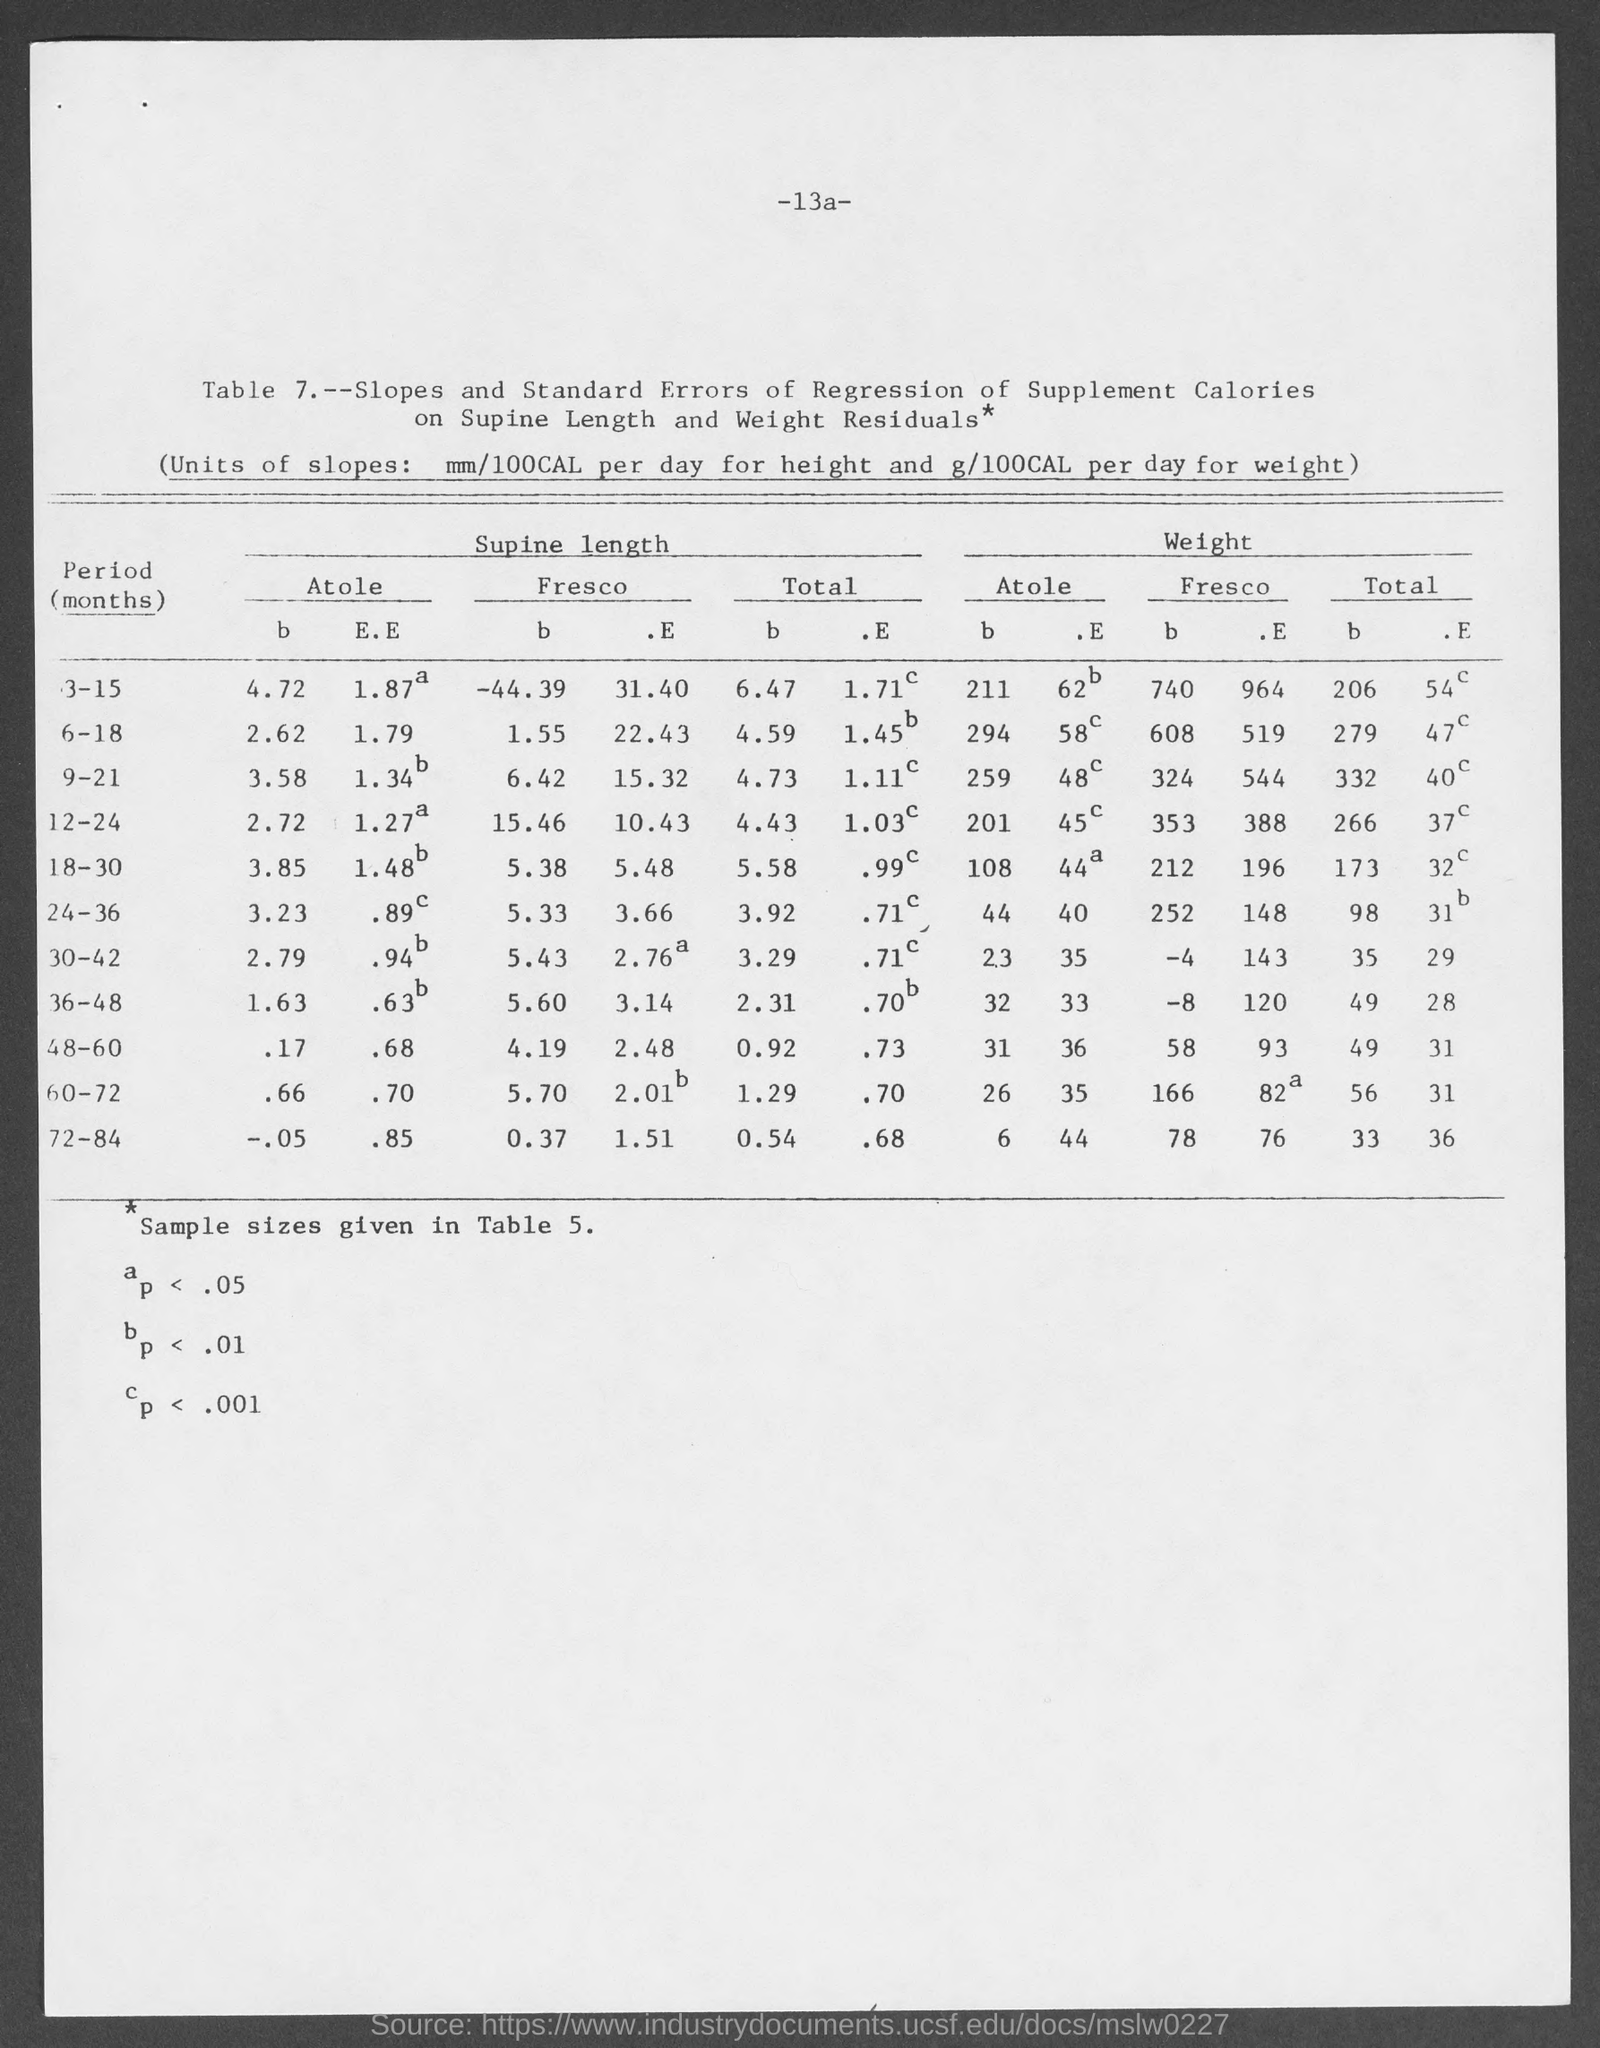Write the Units of Slopes?
Offer a very short reply. Mm/100cal per day for height and g/100cal per day for weight. 